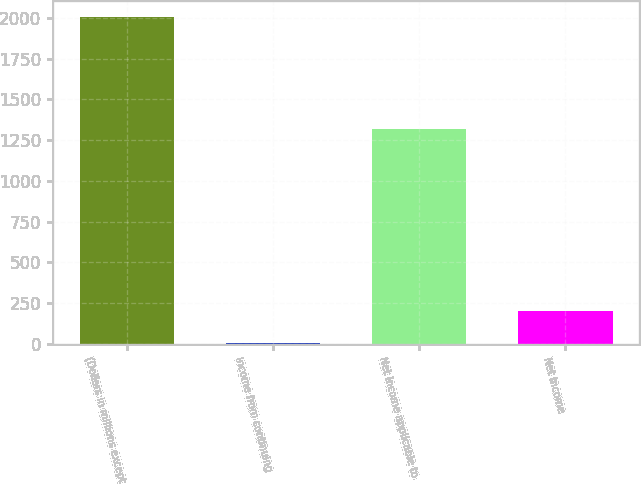Convert chart to OTSL. <chart><loc_0><loc_0><loc_500><loc_500><bar_chart><fcel>(Dollars in millions except<fcel>Income from continuing<fcel>Net income applicable to<fcel>Net income<nl><fcel>2003<fcel>3.26<fcel>1321<fcel>203.23<nl></chart> 